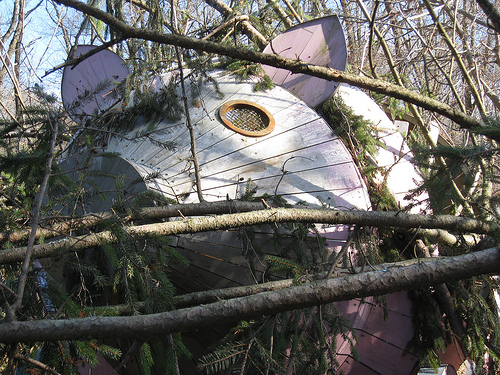<image>
Is there a satellite on the branch? Yes. Looking at the image, I can see the satellite is positioned on top of the branch, with the branch providing support. 